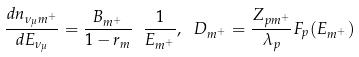Convert formula to latex. <formula><loc_0><loc_0><loc_500><loc_500>\frac { d n _ { \nu _ { \mu } m ^ { + } } } { d E _ { \nu _ { \mu } } } = \frac { B _ { m ^ { + } } } { 1 - r _ { m } } \ \frac { 1 } { E _ { m ^ { + } } } , \ D _ { m ^ { + } } = \frac { Z _ { p m ^ { + } } } { \lambda _ { p } } F _ { p } ( E _ { m ^ { + } } )</formula> 